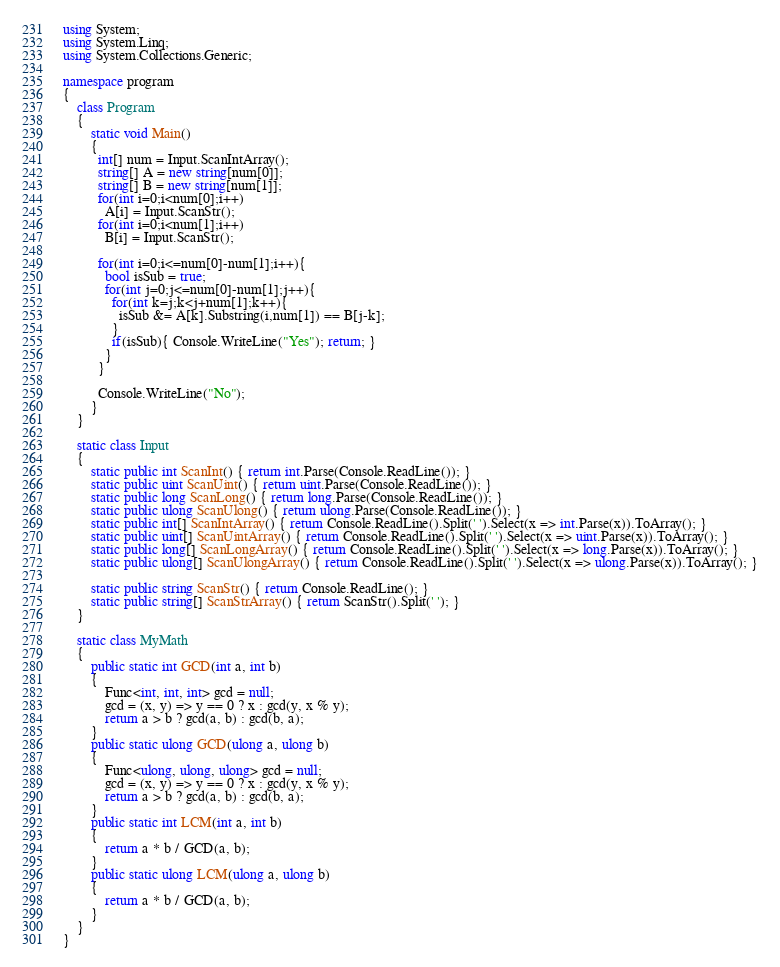<code> <loc_0><loc_0><loc_500><loc_500><_C#_>using System;
using System.Linq;
using System.Collections.Generic;

namespace program
{
    class Program
    {
        static void Main()
        {
          int[] num = Input.ScanIntArray();
          string[] A = new string[num[0]];
          string[] B = new string[num[1]];
          for(int i=0;i<num[0];i++)
            A[i] = Input.ScanStr();
          for(int i=0;i<num[1];i++)
            B[i] = Input.ScanStr();
          
          for(int i=0;i<=num[0]-num[1];i++){
            bool isSub = true;
            for(int j=0;j<=num[0]-num[1];j++){
              for(int k=j;k<j+num[1];k++){
                isSub &= A[k].Substring(i,num[1]) == B[j-k];
              }
              if(isSub){ Console.WriteLine("Yes"); return; }
            }
          }
            
          Console.WriteLine("No");
        }
    }

    static class Input
    {
        static public int ScanInt() { return int.Parse(Console.ReadLine()); }
        static public uint ScanUint() { return uint.Parse(Console.ReadLine()); }
        static public long ScanLong() { return long.Parse(Console.ReadLine()); }
        static public ulong ScanUlong() { return ulong.Parse(Console.ReadLine()); }
        static public int[] ScanIntArray() { return Console.ReadLine().Split(' ').Select(x => int.Parse(x)).ToArray(); }
        static public uint[] ScanUintArray() { return Console.ReadLine().Split(' ').Select(x => uint.Parse(x)).ToArray(); }
        static public long[] ScanLongArray() { return Console.ReadLine().Split(' ').Select(x => long.Parse(x)).ToArray(); }
        static public ulong[] ScanUlongArray() { return Console.ReadLine().Split(' ').Select(x => ulong.Parse(x)).ToArray(); }

        static public string ScanStr() { return Console.ReadLine(); }
        static public string[] ScanStrArray() { return ScanStr().Split(' '); }
    }

    static class MyMath
    {
        public static int GCD(int a, int b)
        {
            Func<int, int, int> gcd = null;
            gcd = (x, y) => y == 0 ? x : gcd(y, x % y);
            return a > b ? gcd(a, b) : gcd(b, a);
        }
        public static ulong GCD(ulong a, ulong b)
        {
            Func<ulong, ulong, ulong> gcd = null;
            gcd = (x, y) => y == 0 ? x : gcd(y, x % y);
            return a > b ? gcd(a, b) : gcd(b, a);
        }
        public static int LCM(int a, int b)
        {
            return a * b / GCD(a, b);
        }
        public static ulong LCM(ulong a, ulong b)
        {
            return a * b / GCD(a, b);
        }
    }
}
</code> 